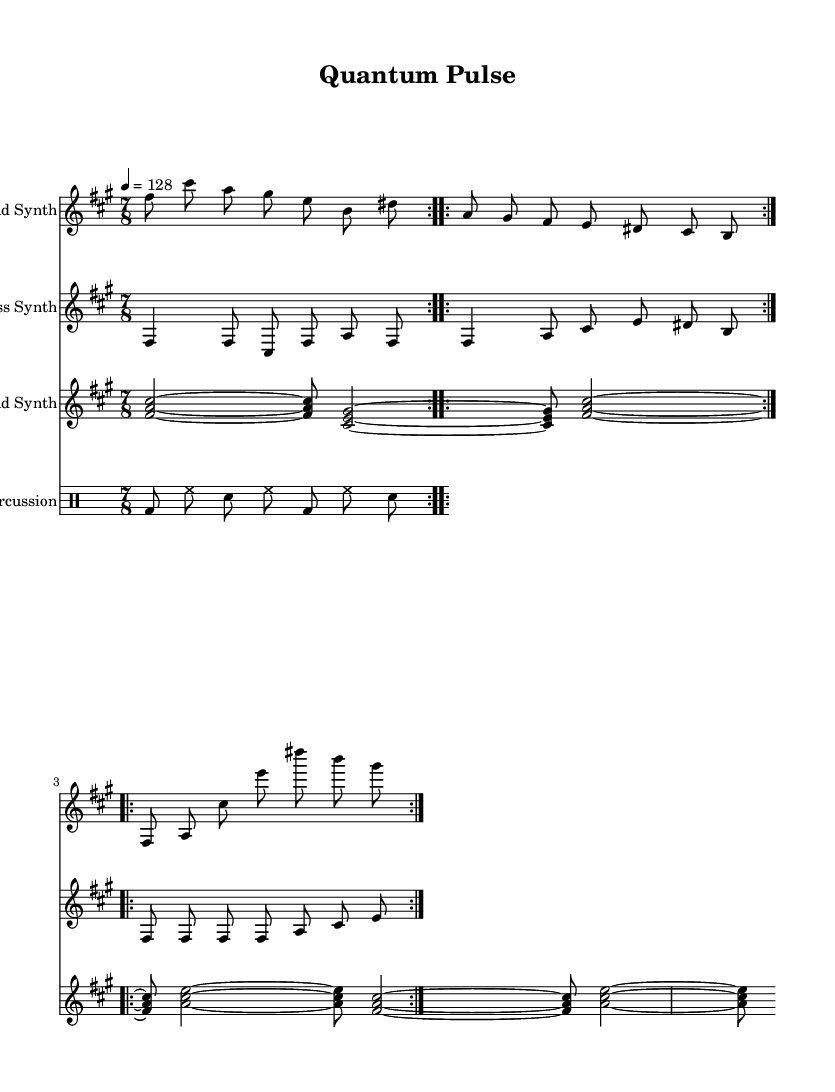What is the key signature of this music? The key signature is indicated by the presence of sharps at the beginning of the staff, showing that the music is in F sharp minor.
Answer: F sharp minor What is the time signature of this music? The time signature is displayed as 7/8 at the beginning of the score, meaning there are seven eighth notes per measure.
Answer: 7/8 What is the tempo marking for this piece? The tempo marking indicates the quarter note should be played at 128 beats per minute. This is shown by the number "4 = 128" alongside the tempo indication.
Answer: 128 How many measures are in the Intro section of the Lead Synth? The intro section is presented in two repeated segments, each of which consists of two measures. Therefore, the total for the intro is 4 measures (2 measures x 2 repetitions).
Answer: 4 Which instruments are involved in the composition? The score includes four different parts, using a Lead Synth, Bass Synth, Pad Synth, and Percussion, showing a blend of electronic and rhythmic elements.
Answer: Lead Synth, Bass Synth, Pad Synth, Percussion How is the rhythm varied in the Percussion part? The percussion part uses a basic pattern that alternates between bass drum, hi-hat, and snare, demonstrating a simple but rhythmic structure typical in EDM. The use of eighth notes creates a driving rhythm.
Answer: Alternating pattern What unconventional element is present in this piece? The piece utilizes an unconventional time signature of 7/8, which is less common in typical EDM, showcasing a more avant-garde approach to electronic music composition.
Answer: 7/8 